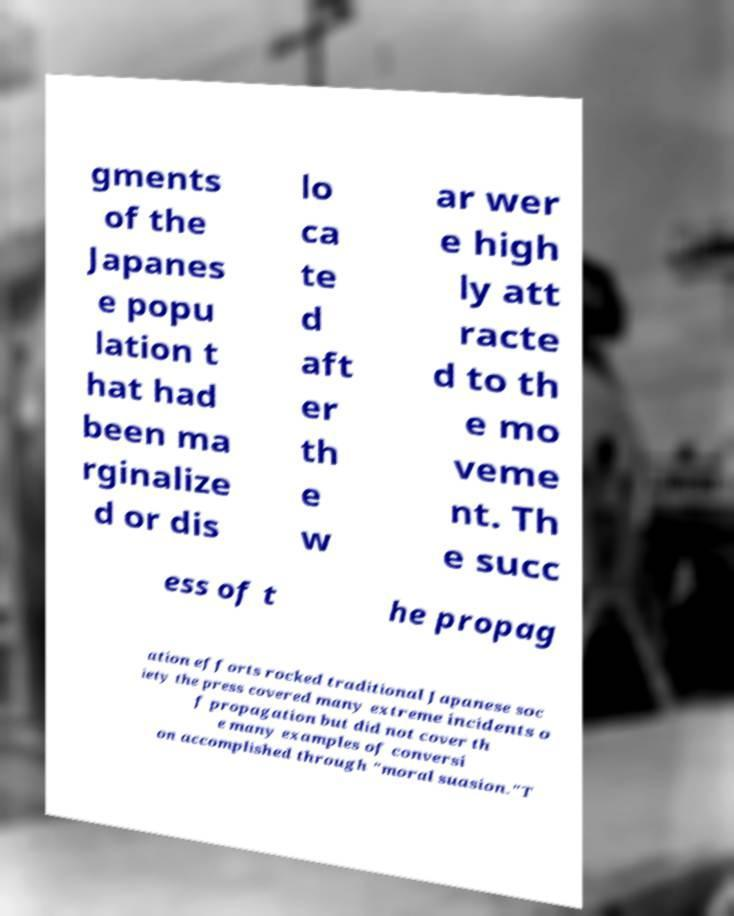Can you accurately transcribe the text from the provided image for me? gments of the Japanes e popu lation t hat had been ma rginalize d or dis lo ca te d aft er th e w ar wer e high ly att racte d to th e mo veme nt. Th e succ ess of t he propag ation efforts rocked traditional Japanese soc iety the press covered many extreme incidents o f propagation but did not cover th e many examples of conversi on accomplished through "moral suasion."T 